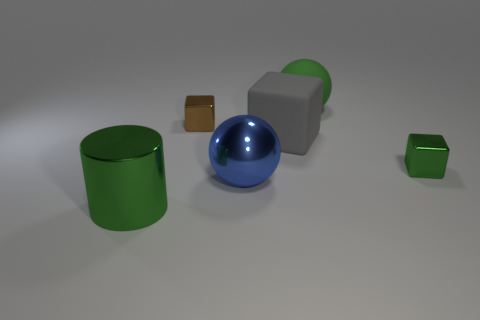What materials do the objects in the image seem to be made of? The objects in the image appear to be rendered with different material properties. The cylinder and the small cube seem to have a shiny, reflective surface, suggesting a metallic material, whereas the large cube has a diffuse appearance, more like plastic or painted metal. The ball also has a reflective quality, hinting at a glossy painted surface or a polished metal. 